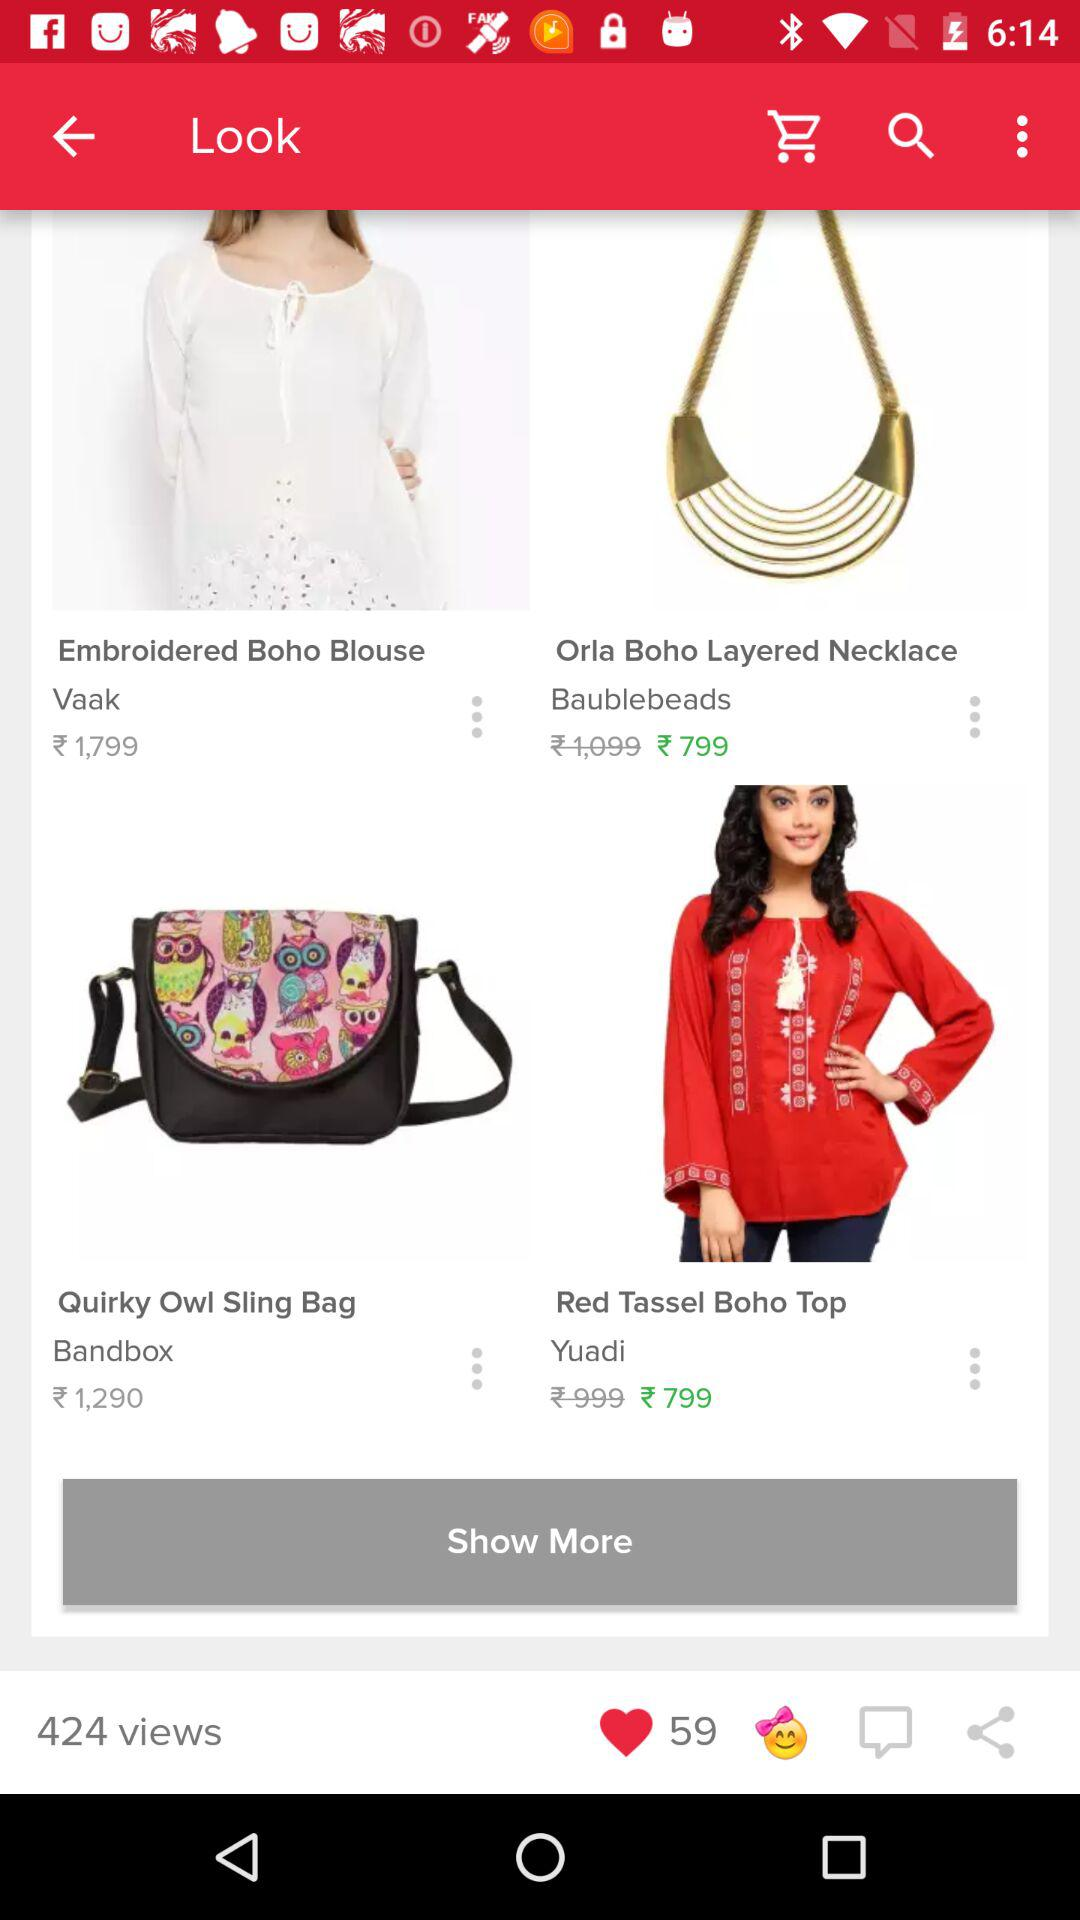What is the price of the quirky owl sling bag? The price of the quirky owl sling bag is 1,290 rupees. 